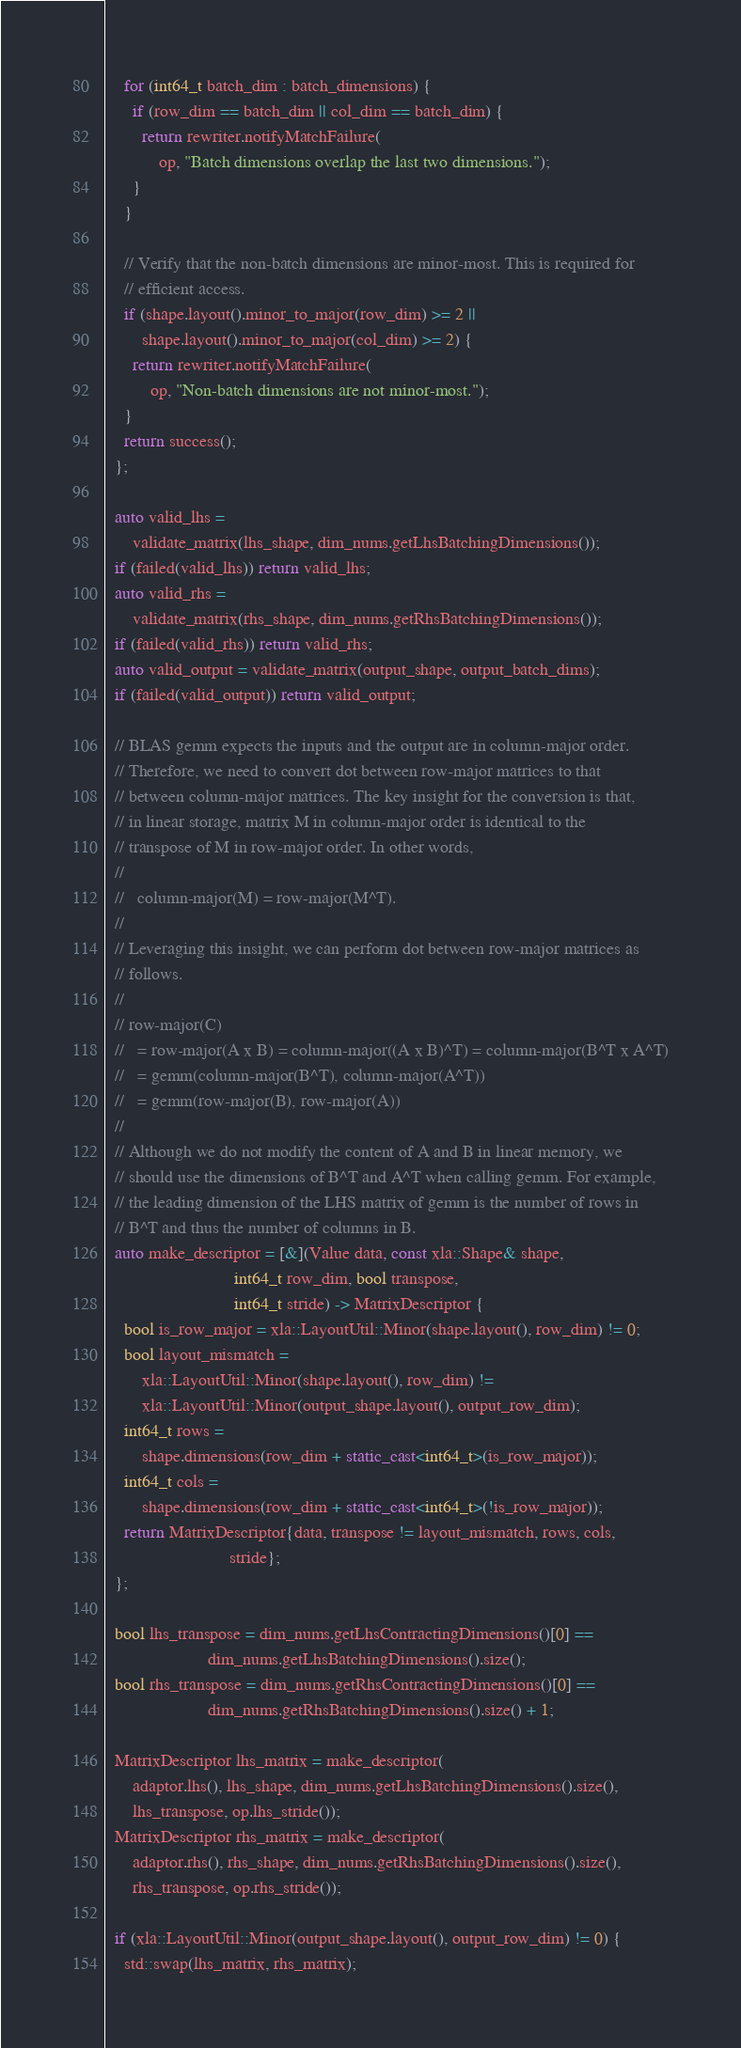<code> <loc_0><loc_0><loc_500><loc_500><_C++_>    for (int64_t batch_dim : batch_dimensions) {
      if (row_dim == batch_dim || col_dim == batch_dim) {
        return rewriter.notifyMatchFailure(
            op, "Batch dimensions overlap the last two dimensions.");
      }
    }

    // Verify that the non-batch dimensions are minor-most. This is required for
    // efficient access.
    if (shape.layout().minor_to_major(row_dim) >= 2 ||
        shape.layout().minor_to_major(col_dim) >= 2) {
      return rewriter.notifyMatchFailure(
          op, "Non-batch dimensions are not minor-most.");
    }
    return success();
  };

  auto valid_lhs =
      validate_matrix(lhs_shape, dim_nums.getLhsBatchingDimensions());
  if (failed(valid_lhs)) return valid_lhs;
  auto valid_rhs =
      validate_matrix(rhs_shape, dim_nums.getRhsBatchingDimensions());
  if (failed(valid_rhs)) return valid_rhs;
  auto valid_output = validate_matrix(output_shape, output_batch_dims);
  if (failed(valid_output)) return valid_output;

  // BLAS gemm expects the inputs and the output are in column-major order.
  // Therefore, we need to convert dot between row-major matrices to that
  // between column-major matrices. The key insight for the conversion is that,
  // in linear storage, matrix M in column-major order is identical to the
  // transpose of M in row-major order. In other words,
  //
  //   column-major(M) = row-major(M^T).
  //
  // Leveraging this insight, we can perform dot between row-major matrices as
  // follows.
  //
  // row-major(C)
  //   = row-major(A x B) = column-major((A x B)^T) = column-major(B^T x A^T)
  //   = gemm(column-major(B^T), column-major(A^T))
  //   = gemm(row-major(B), row-major(A))
  //
  // Although we do not modify the content of A and B in linear memory, we
  // should use the dimensions of B^T and A^T when calling gemm. For example,
  // the leading dimension of the LHS matrix of gemm is the number of rows in
  // B^T and thus the number of columns in B.
  auto make_descriptor = [&](Value data, const xla::Shape& shape,
                             int64_t row_dim, bool transpose,
                             int64_t stride) -> MatrixDescriptor {
    bool is_row_major = xla::LayoutUtil::Minor(shape.layout(), row_dim) != 0;
    bool layout_mismatch =
        xla::LayoutUtil::Minor(shape.layout(), row_dim) !=
        xla::LayoutUtil::Minor(output_shape.layout(), output_row_dim);
    int64_t rows =
        shape.dimensions(row_dim + static_cast<int64_t>(is_row_major));
    int64_t cols =
        shape.dimensions(row_dim + static_cast<int64_t>(!is_row_major));
    return MatrixDescriptor{data, transpose != layout_mismatch, rows, cols,
                            stride};
  };

  bool lhs_transpose = dim_nums.getLhsContractingDimensions()[0] ==
                       dim_nums.getLhsBatchingDimensions().size();
  bool rhs_transpose = dim_nums.getRhsContractingDimensions()[0] ==
                       dim_nums.getRhsBatchingDimensions().size() + 1;

  MatrixDescriptor lhs_matrix = make_descriptor(
      adaptor.lhs(), lhs_shape, dim_nums.getLhsBatchingDimensions().size(),
      lhs_transpose, op.lhs_stride());
  MatrixDescriptor rhs_matrix = make_descriptor(
      adaptor.rhs(), rhs_shape, dim_nums.getRhsBatchingDimensions().size(),
      rhs_transpose, op.rhs_stride());

  if (xla::LayoutUtil::Minor(output_shape.layout(), output_row_dim) != 0) {
    std::swap(lhs_matrix, rhs_matrix);</code> 